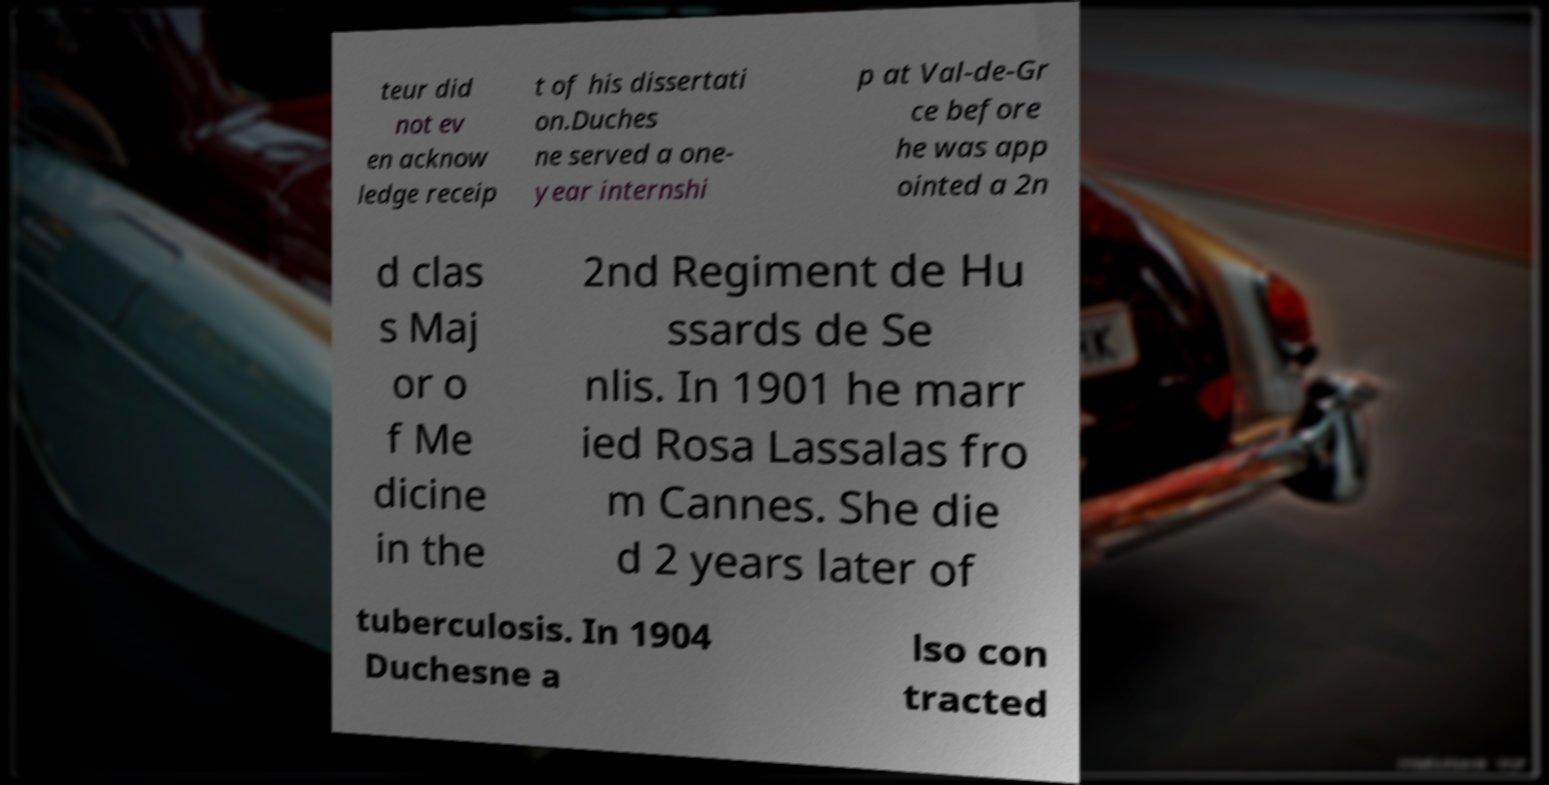Please identify and transcribe the text found in this image. teur did not ev en acknow ledge receip t of his dissertati on.Duches ne served a one- year internshi p at Val-de-Gr ce before he was app ointed a 2n d clas s Maj or o f Me dicine in the 2nd Regiment de Hu ssards de Se nlis. In 1901 he marr ied Rosa Lassalas fro m Cannes. She die d 2 years later of tuberculosis. In 1904 Duchesne a lso con tracted 